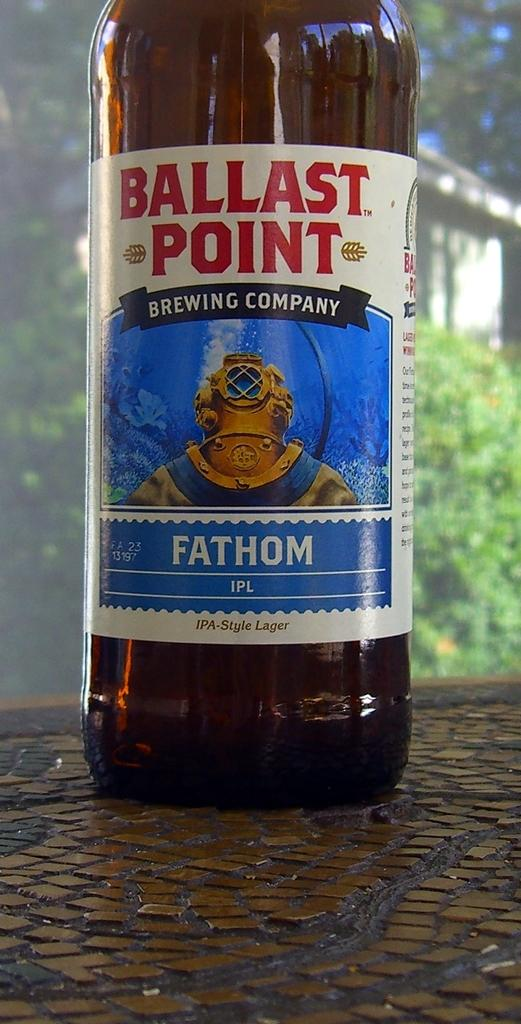<image>
Create a compact narrative representing the image presented. A bottle of beer with the words Brewing Company on the label. 